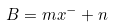Convert formula to latex. <formula><loc_0><loc_0><loc_500><loc_500>B = m x ^ { - } + n</formula> 